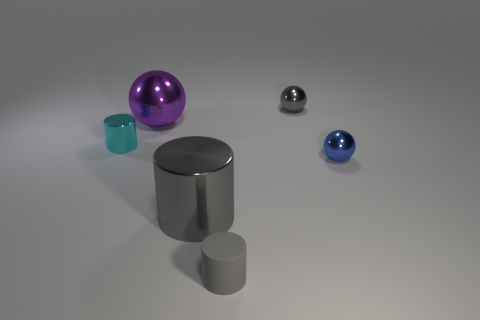Can you describe the colors and materials of the objects shown? Certainly! There is a range of colors and materials displayed. From left to right, you see a small translucent teal cube that resembles glass, a larger shiny purple sphere that looks metallic, a small reflective silver cylinder that could be made of metal, and a more matte cylinder in a similar shade of gray. Additionally, a small metallic ball and a smaller blue sphere which also have reflective surfaces indicating a metallic quality. 